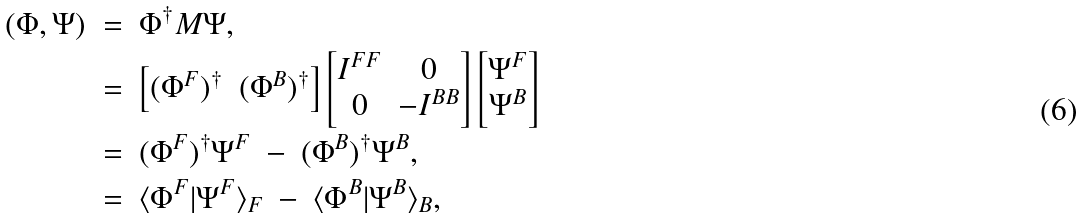Convert formula to latex. <formula><loc_0><loc_0><loc_500><loc_500>( \Phi , \Psi ) \ & = \ \Phi ^ { \dagger } M \Psi , \\ & = \ \left [ \begin{matrix} ( \Phi ^ { F } ) ^ { \dagger } & ( \Phi ^ { B } ) ^ { \dagger } \end{matrix} \right ] \left [ \begin{matrix} I ^ { F F } & 0 \\ 0 & - I ^ { B B } \end{matrix} \right ] \left [ \begin{matrix} \Psi ^ { F } \\ \Psi ^ { B } \end{matrix} \right ] \\ & = \ ( \Phi ^ { F } ) ^ { \dagger } \Psi ^ { F } \ - \ ( \Phi ^ { B } ) ^ { \dagger } \Psi ^ { B } , \\ & = \ \langle \Phi ^ { F } | \Psi ^ { F } \rangle _ { F } \ - \ \langle \Phi ^ { B } | \Psi ^ { B } \rangle _ { B } ,</formula> 